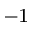<formula> <loc_0><loc_0><loc_500><loc_500>^ { - 1 }</formula> 